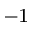<formula> <loc_0><loc_0><loc_500><loc_500>^ { - 1 }</formula> 